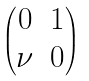<formula> <loc_0><loc_0><loc_500><loc_500>\begin{pmatrix} 0 & 1 \\ \nu & 0 \end{pmatrix}</formula> 